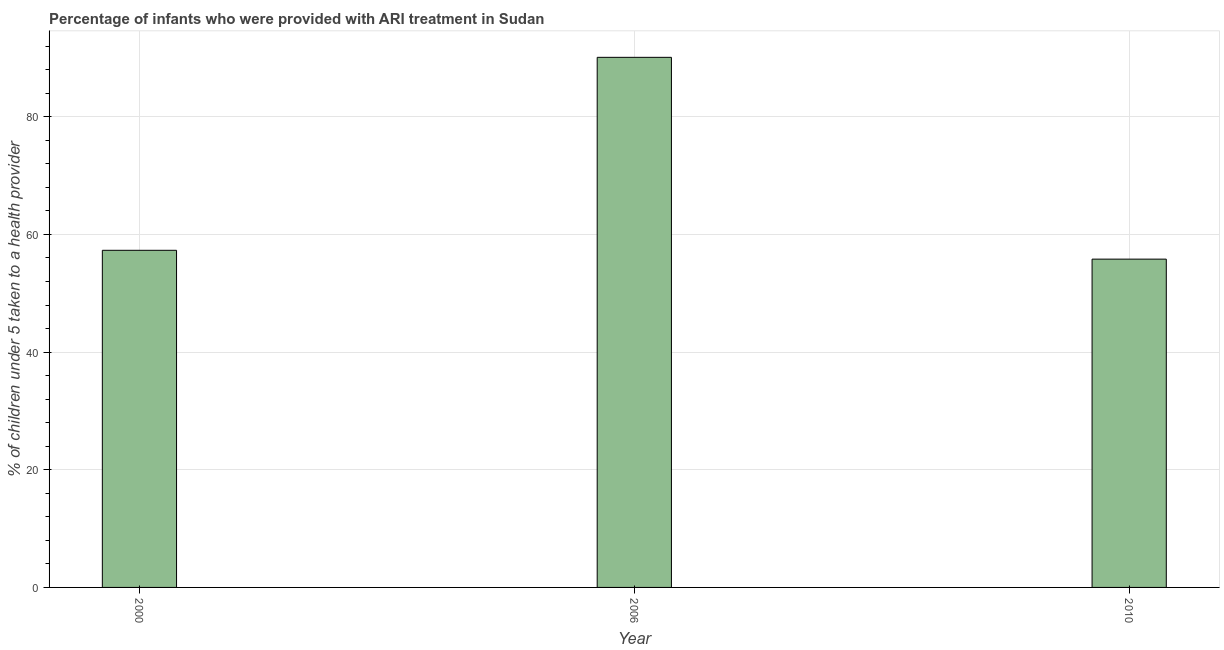Does the graph contain any zero values?
Give a very brief answer. No. Does the graph contain grids?
Provide a succinct answer. Yes. What is the title of the graph?
Give a very brief answer. Percentage of infants who were provided with ARI treatment in Sudan. What is the label or title of the X-axis?
Your response must be concise. Year. What is the label or title of the Y-axis?
Offer a terse response. % of children under 5 taken to a health provider. What is the percentage of children who were provided with ari treatment in 2000?
Your answer should be compact. 57.3. Across all years, what is the maximum percentage of children who were provided with ari treatment?
Make the answer very short. 90.1. Across all years, what is the minimum percentage of children who were provided with ari treatment?
Provide a short and direct response. 55.8. In which year was the percentage of children who were provided with ari treatment minimum?
Your response must be concise. 2010. What is the sum of the percentage of children who were provided with ari treatment?
Offer a terse response. 203.2. What is the difference between the percentage of children who were provided with ari treatment in 2000 and 2010?
Your response must be concise. 1.5. What is the average percentage of children who were provided with ari treatment per year?
Ensure brevity in your answer.  67.73. What is the median percentage of children who were provided with ari treatment?
Provide a succinct answer. 57.3. In how many years, is the percentage of children who were provided with ari treatment greater than 8 %?
Provide a short and direct response. 3. What is the ratio of the percentage of children who were provided with ari treatment in 2000 to that in 2006?
Offer a terse response. 0.64. Is the difference between the percentage of children who were provided with ari treatment in 2006 and 2010 greater than the difference between any two years?
Offer a very short reply. Yes. What is the difference between the highest and the second highest percentage of children who were provided with ari treatment?
Provide a short and direct response. 32.8. What is the difference between the highest and the lowest percentage of children who were provided with ari treatment?
Provide a succinct answer. 34.3. In how many years, is the percentage of children who were provided with ari treatment greater than the average percentage of children who were provided with ari treatment taken over all years?
Provide a short and direct response. 1. Are all the bars in the graph horizontal?
Your answer should be very brief. No. What is the difference between two consecutive major ticks on the Y-axis?
Your response must be concise. 20. Are the values on the major ticks of Y-axis written in scientific E-notation?
Keep it short and to the point. No. What is the % of children under 5 taken to a health provider in 2000?
Offer a very short reply. 57.3. What is the % of children under 5 taken to a health provider of 2006?
Make the answer very short. 90.1. What is the % of children under 5 taken to a health provider of 2010?
Keep it short and to the point. 55.8. What is the difference between the % of children under 5 taken to a health provider in 2000 and 2006?
Offer a terse response. -32.8. What is the difference between the % of children under 5 taken to a health provider in 2000 and 2010?
Give a very brief answer. 1.5. What is the difference between the % of children under 5 taken to a health provider in 2006 and 2010?
Make the answer very short. 34.3. What is the ratio of the % of children under 5 taken to a health provider in 2000 to that in 2006?
Ensure brevity in your answer.  0.64. What is the ratio of the % of children under 5 taken to a health provider in 2000 to that in 2010?
Your answer should be compact. 1.03. What is the ratio of the % of children under 5 taken to a health provider in 2006 to that in 2010?
Keep it short and to the point. 1.61. 